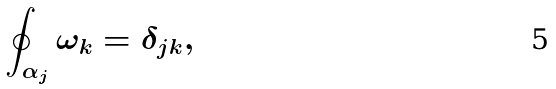Convert formula to latex. <formula><loc_0><loc_0><loc_500><loc_500>\oint _ { \alpha _ { j } } \omega _ { k } = \delta _ { j k } ,</formula> 